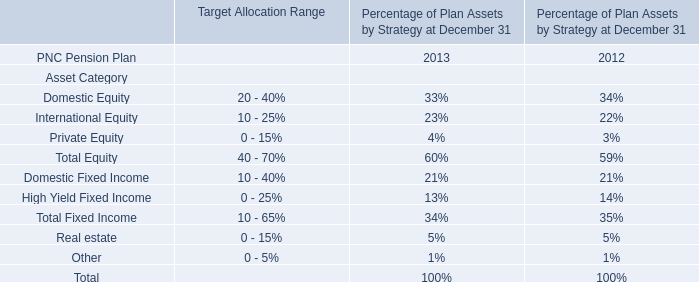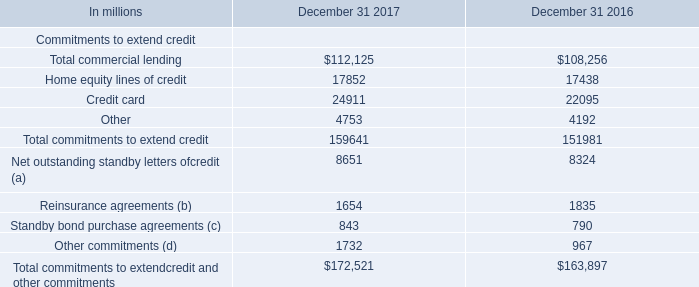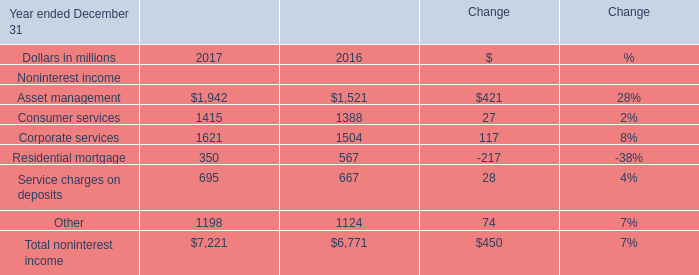What was the average value of the Corporate services for Noninterest income in the years where Asset management for Noninterest income is positive? (in million) 
Computations: ((1621 + 1504) / 2)
Answer: 1562.5. 